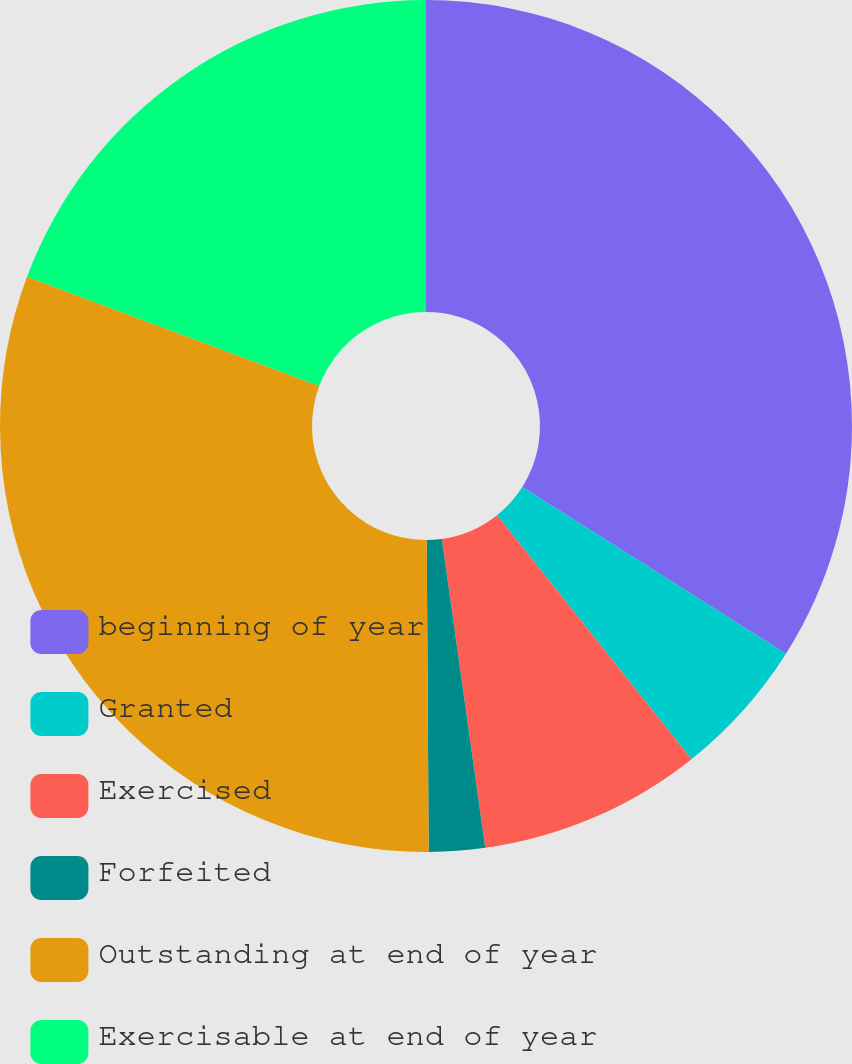<chart> <loc_0><loc_0><loc_500><loc_500><pie_chart><fcel>beginning of year<fcel>Granted<fcel>Exercised<fcel>Forfeited<fcel>Outstanding at end of year<fcel>Exercisable at end of year<nl><fcel>33.98%<fcel>5.31%<fcel>8.49%<fcel>2.12%<fcel>30.8%<fcel>19.3%<nl></chart> 